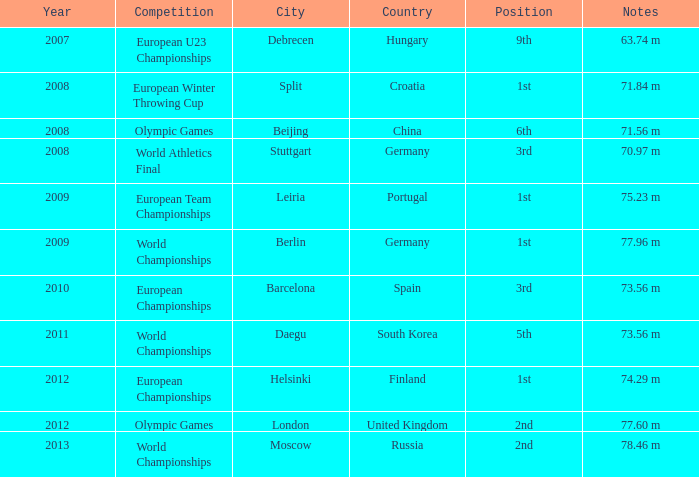Can you give me this table as a dict? {'header': ['Year', 'Competition', 'City', 'Country', 'Position', 'Notes'], 'rows': [['2007', 'European U23 Championships', 'Debrecen', 'Hungary', '9th', '63.74 m'], ['2008', 'European Winter Throwing Cup', 'Split', 'Croatia', '1st', '71.84 m'], ['2008', 'Olympic Games', 'Beijing', 'China', '6th', '71.56 m'], ['2008', 'World Athletics Final', 'Stuttgart', 'Germany', '3rd', '70.97 m'], ['2009', 'European Team Championships', 'Leiria', 'Portugal', '1st', '75.23 m'], ['2009', 'World Championships', 'Berlin', 'Germany', '1st', '77.96 m'], ['2010', 'European Championships', 'Barcelona', 'Spain', '3rd', '73.56 m'], ['2011', 'World Championships', 'Daegu', 'South Korea', '5th', '73.56 m'], ['2012', 'European Championships', 'Helsinki', 'Finland', '1st', '74.29 m'], ['2012', 'Olympic Games', 'London', 'United Kingdom', '2nd', '77.60 m'], ['2013', 'World Championships', 'Moscow', 'Russia', '2nd', '78.46 m']]} What was the venue after 2012? Moscow, Russia. 